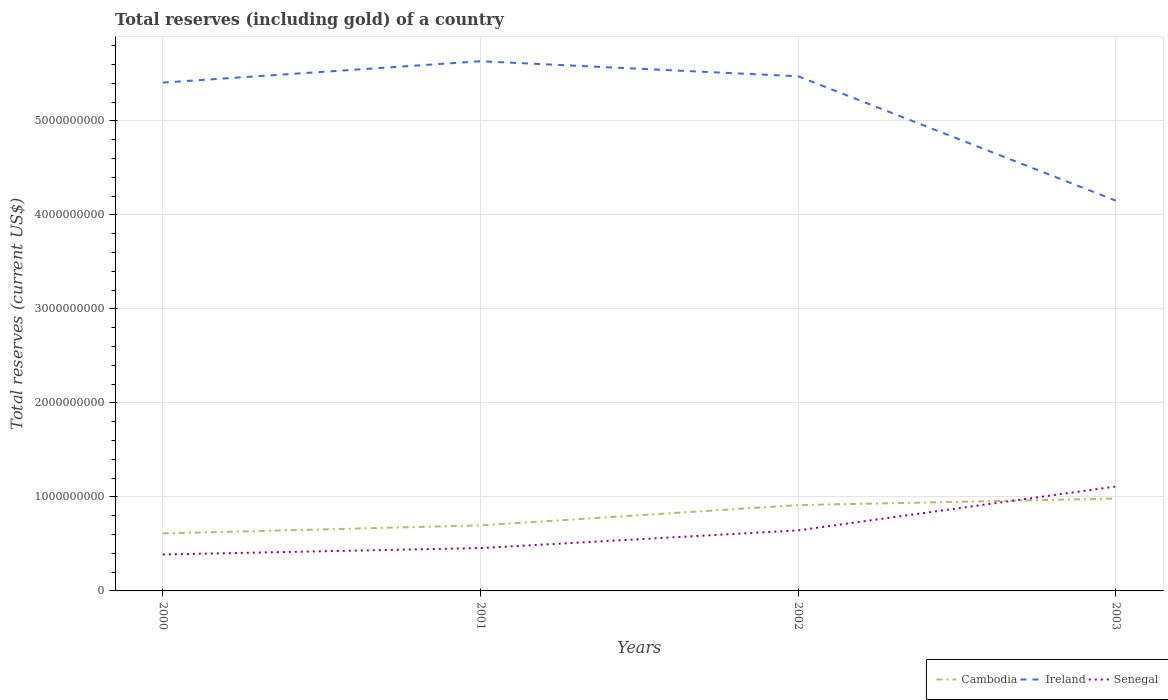Across all years, what is the maximum total reserves (including gold) in Senegal?
Give a very brief answer. 3.88e+08. In which year was the total reserves (including gold) in Senegal maximum?
Your answer should be compact. 2000. What is the total total reserves (including gold) in Ireland in the graph?
Your answer should be compact. 1.60e+08. What is the difference between the highest and the second highest total reserves (including gold) in Cambodia?
Give a very brief answer. 3.71e+08. Is the total reserves (including gold) in Senegal strictly greater than the total reserves (including gold) in Ireland over the years?
Make the answer very short. Yes. How many lines are there?
Offer a very short reply. 3. What is the difference between two consecutive major ticks on the Y-axis?
Make the answer very short. 1.00e+09. Does the graph contain any zero values?
Provide a short and direct response. No. Does the graph contain grids?
Your response must be concise. Yes. How are the legend labels stacked?
Provide a short and direct response. Horizontal. What is the title of the graph?
Provide a succinct answer. Total reserves (including gold) of a country. What is the label or title of the Y-axis?
Keep it short and to the point. Total reserves (current US$). What is the Total reserves (current US$) in Cambodia in 2000?
Give a very brief answer. 6.11e+08. What is the Total reserves (current US$) of Ireland in 2000?
Keep it short and to the point. 5.41e+09. What is the Total reserves (current US$) of Senegal in 2000?
Provide a short and direct response. 3.88e+08. What is the Total reserves (current US$) of Cambodia in 2001?
Provide a short and direct response. 6.97e+08. What is the Total reserves (current US$) of Ireland in 2001?
Give a very brief answer. 5.64e+09. What is the Total reserves (current US$) of Senegal in 2001?
Give a very brief answer. 4.56e+08. What is the Total reserves (current US$) in Cambodia in 2002?
Give a very brief answer. 9.13e+08. What is the Total reserves (current US$) of Ireland in 2002?
Offer a terse response. 5.48e+09. What is the Total reserves (current US$) in Senegal in 2002?
Provide a succinct answer. 6.44e+08. What is the Total reserves (current US$) of Cambodia in 2003?
Offer a terse response. 9.82e+08. What is the Total reserves (current US$) of Ireland in 2003?
Your answer should be compact. 4.15e+09. What is the Total reserves (current US$) in Senegal in 2003?
Offer a terse response. 1.11e+09. Across all years, what is the maximum Total reserves (current US$) in Cambodia?
Provide a succinct answer. 9.82e+08. Across all years, what is the maximum Total reserves (current US$) of Ireland?
Offer a terse response. 5.64e+09. Across all years, what is the maximum Total reserves (current US$) of Senegal?
Your answer should be very brief. 1.11e+09. Across all years, what is the minimum Total reserves (current US$) of Cambodia?
Provide a short and direct response. 6.11e+08. Across all years, what is the minimum Total reserves (current US$) of Ireland?
Offer a terse response. 4.15e+09. Across all years, what is the minimum Total reserves (current US$) in Senegal?
Keep it short and to the point. 3.88e+08. What is the total Total reserves (current US$) of Cambodia in the graph?
Ensure brevity in your answer.  3.20e+09. What is the total Total reserves (current US$) of Ireland in the graph?
Your response must be concise. 2.07e+1. What is the total Total reserves (current US$) in Senegal in the graph?
Ensure brevity in your answer.  2.60e+09. What is the difference between the Total reserves (current US$) of Cambodia in 2000 and that in 2001?
Ensure brevity in your answer.  -8.59e+07. What is the difference between the Total reserves (current US$) of Ireland in 2000 and that in 2001?
Offer a very short reply. -2.27e+08. What is the difference between the Total reserves (current US$) in Senegal in 2000 and that in 2001?
Offer a very short reply. -6.83e+07. What is the difference between the Total reserves (current US$) of Cambodia in 2000 and that in 2002?
Offer a very short reply. -3.02e+08. What is the difference between the Total reserves (current US$) of Ireland in 2000 and that in 2002?
Provide a short and direct response. -6.72e+07. What is the difference between the Total reserves (current US$) in Senegal in 2000 and that in 2002?
Keep it short and to the point. -2.57e+08. What is the difference between the Total reserves (current US$) in Cambodia in 2000 and that in 2003?
Your answer should be very brief. -3.71e+08. What is the difference between the Total reserves (current US$) of Ireland in 2000 and that in 2003?
Offer a very short reply. 1.26e+09. What is the difference between the Total reserves (current US$) in Senegal in 2000 and that in 2003?
Give a very brief answer. -7.23e+08. What is the difference between the Total reserves (current US$) in Cambodia in 2001 and that in 2002?
Keep it short and to the point. -2.16e+08. What is the difference between the Total reserves (current US$) of Ireland in 2001 and that in 2002?
Offer a very short reply. 1.60e+08. What is the difference between the Total reserves (current US$) in Senegal in 2001 and that in 2002?
Keep it short and to the point. -1.88e+08. What is the difference between the Total reserves (current US$) of Cambodia in 2001 and that in 2003?
Provide a succinct answer. -2.85e+08. What is the difference between the Total reserves (current US$) in Ireland in 2001 and that in 2003?
Keep it short and to the point. 1.48e+09. What is the difference between the Total reserves (current US$) of Senegal in 2001 and that in 2003?
Ensure brevity in your answer.  -6.55e+08. What is the difference between the Total reserves (current US$) of Cambodia in 2002 and that in 2003?
Your answer should be compact. -6.92e+07. What is the difference between the Total reserves (current US$) in Ireland in 2002 and that in 2003?
Provide a succinct answer. 1.32e+09. What is the difference between the Total reserves (current US$) of Senegal in 2002 and that in 2003?
Your answer should be very brief. -4.67e+08. What is the difference between the Total reserves (current US$) in Cambodia in 2000 and the Total reserves (current US$) in Ireland in 2001?
Provide a short and direct response. -5.02e+09. What is the difference between the Total reserves (current US$) of Cambodia in 2000 and the Total reserves (current US$) of Senegal in 2001?
Give a very brief answer. 1.56e+08. What is the difference between the Total reserves (current US$) of Ireland in 2000 and the Total reserves (current US$) of Senegal in 2001?
Give a very brief answer. 4.95e+09. What is the difference between the Total reserves (current US$) in Cambodia in 2000 and the Total reserves (current US$) in Ireland in 2002?
Give a very brief answer. -4.86e+09. What is the difference between the Total reserves (current US$) of Cambodia in 2000 and the Total reserves (current US$) of Senegal in 2002?
Give a very brief answer. -3.30e+07. What is the difference between the Total reserves (current US$) of Ireland in 2000 and the Total reserves (current US$) of Senegal in 2002?
Provide a short and direct response. 4.76e+09. What is the difference between the Total reserves (current US$) of Cambodia in 2000 and the Total reserves (current US$) of Ireland in 2003?
Keep it short and to the point. -3.54e+09. What is the difference between the Total reserves (current US$) in Cambodia in 2000 and the Total reserves (current US$) in Senegal in 2003?
Your answer should be compact. -5.00e+08. What is the difference between the Total reserves (current US$) in Ireland in 2000 and the Total reserves (current US$) in Senegal in 2003?
Your answer should be very brief. 4.30e+09. What is the difference between the Total reserves (current US$) of Cambodia in 2001 and the Total reserves (current US$) of Ireland in 2002?
Keep it short and to the point. -4.78e+09. What is the difference between the Total reserves (current US$) of Cambodia in 2001 and the Total reserves (current US$) of Senegal in 2002?
Provide a succinct answer. 5.30e+07. What is the difference between the Total reserves (current US$) of Ireland in 2001 and the Total reserves (current US$) of Senegal in 2002?
Offer a terse response. 4.99e+09. What is the difference between the Total reserves (current US$) of Cambodia in 2001 and the Total reserves (current US$) of Ireland in 2003?
Give a very brief answer. -3.45e+09. What is the difference between the Total reserves (current US$) of Cambodia in 2001 and the Total reserves (current US$) of Senegal in 2003?
Your response must be concise. -4.14e+08. What is the difference between the Total reserves (current US$) in Ireland in 2001 and the Total reserves (current US$) in Senegal in 2003?
Provide a succinct answer. 4.52e+09. What is the difference between the Total reserves (current US$) of Cambodia in 2002 and the Total reserves (current US$) of Ireland in 2003?
Your answer should be compact. -3.24e+09. What is the difference between the Total reserves (current US$) in Cambodia in 2002 and the Total reserves (current US$) in Senegal in 2003?
Keep it short and to the point. -1.98e+08. What is the difference between the Total reserves (current US$) in Ireland in 2002 and the Total reserves (current US$) in Senegal in 2003?
Ensure brevity in your answer.  4.36e+09. What is the average Total reserves (current US$) in Cambodia per year?
Offer a very short reply. 8.01e+08. What is the average Total reserves (current US$) of Ireland per year?
Keep it short and to the point. 5.17e+09. What is the average Total reserves (current US$) of Senegal per year?
Give a very brief answer. 6.50e+08. In the year 2000, what is the difference between the Total reserves (current US$) of Cambodia and Total reserves (current US$) of Ireland?
Your answer should be very brief. -4.80e+09. In the year 2000, what is the difference between the Total reserves (current US$) in Cambodia and Total reserves (current US$) in Senegal?
Keep it short and to the point. 2.24e+08. In the year 2000, what is the difference between the Total reserves (current US$) of Ireland and Total reserves (current US$) of Senegal?
Make the answer very short. 5.02e+09. In the year 2001, what is the difference between the Total reserves (current US$) in Cambodia and Total reserves (current US$) in Ireland?
Provide a short and direct response. -4.94e+09. In the year 2001, what is the difference between the Total reserves (current US$) of Cambodia and Total reserves (current US$) of Senegal?
Offer a very short reply. 2.41e+08. In the year 2001, what is the difference between the Total reserves (current US$) of Ireland and Total reserves (current US$) of Senegal?
Ensure brevity in your answer.  5.18e+09. In the year 2002, what is the difference between the Total reserves (current US$) in Cambodia and Total reserves (current US$) in Ireland?
Provide a succinct answer. -4.56e+09. In the year 2002, what is the difference between the Total reserves (current US$) in Cambodia and Total reserves (current US$) in Senegal?
Make the answer very short. 2.69e+08. In the year 2002, what is the difference between the Total reserves (current US$) of Ireland and Total reserves (current US$) of Senegal?
Your answer should be compact. 4.83e+09. In the year 2003, what is the difference between the Total reserves (current US$) in Cambodia and Total reserves (current US$) in Ireland?
Make the answer very short. -3.17e+09. In the year 2003, what is the difference between the Total reserves (current US$) of Cambodia and Total reserves (current US$) of Senegal?
Offer a very short reply. -1.29e+08. In the year 2003, what is the difference between the Total reserves (current US$) of Ireland and Total reserves (current US$) of Senegal?
Your answer should be compact. 3.04e+09. What is the ratio of the Total reserves (current US$) in Cambodia in 2000 to that in 2001?
Your answer should be very brief. 0.88. What is the ratio of the Total reserves (current US$) in Ireland in 2000 to that in 2001?
Keep it short and to the point. 0.96. What is the ratio of the Total reserves (current US$) in Senegal in 2000 to that in 2001?
Provide a succinct answer. 0.85. What is the ratio of the Total reserves (current US$) of Cambodia in 2000 to that in 2002?
Make the answer very short. 0.67. What is the ratio of the Total reserves (current US$) of Senegal in 2000 to that in 2002?
Keep it short and to the point. 0.6. What is the ratio of the Total reserves (current US$) of Cambodia in 2000 to that in 2003?
Offer a very short reply. 0.62. What is the ratio of the Total reserves (current US$) in Ireland in 2000 to that in 2003?
Give a very brief answer. 1.3. What is the ratio of the Total reserves (current US$) of Senegal in 2000 to that in 2003?
Provide a succinct answer. 0.35. What is the ratio of the Total reserves (current US$) in Cambodia in 2001 to that in 2002?
Ensure brevity in your answer.  0.76. What is the ratio of the Total reserves (current US$) of Ireland in 2001 to that in 2002?
Make the answer very short. 1.03. What is the ratio of the Total reserves (current US$) in Senegal in 2001 to that in 2002?
Your answer should be very brief. 0.71. What is the ratio of the Total reserves (current US$) in Cambodia in 2001 to that in 2003?
Make the answer very short. 0.71. What is the ratio of the Total reserves (current US$) of Ireland in 2001 to that in 2003?
Ensure brevity in your answer.  1.36. What is the ratio of the Total reserves (current US$) of Senegal in 2001 to that in 2003?
Give a very brief answer. 0.41. What is the ratio of the Total reserves (current US$) in Cambodia in 2002 to that in 2003?
Ensure brevity in your answer.  0.93. What is the ratio of the Total reserves (current US$) in Ireland in 2002 to that in 2003?
Keep it short and to the point. 1.32. What is the ratio of the Total reserves (current US$) of Senegal in 2002 to that in 2003?
Give a very brief answer. 0.58. What is the difference between the highest and the second highest Total reserves (current US$) of Cambodia?
Give a very brief answer. 6.92e+07. What is the difference between the highest and the second highest Total reserves (current US$) of Ireland?
Offer a very short reply. 1.60e+08. What is the difference between the highest and the second highest Total reserves (current US$) of Senegal?
Make the answer very short. 4.67e+08. What is the difference between the highest and the lowest Total reserves (current US$) of Cambodia?
Give a very brief answer. 3.71e+08. What is the difference between the highest and the lowest Total reserves (current US$) in Ireland?
Make the answer very short. 1.48e+09. What is the difference between the highest and the lowest Total reserves (current US$) in Senegal?
Provide a succinct answer. 7.23e+08. 